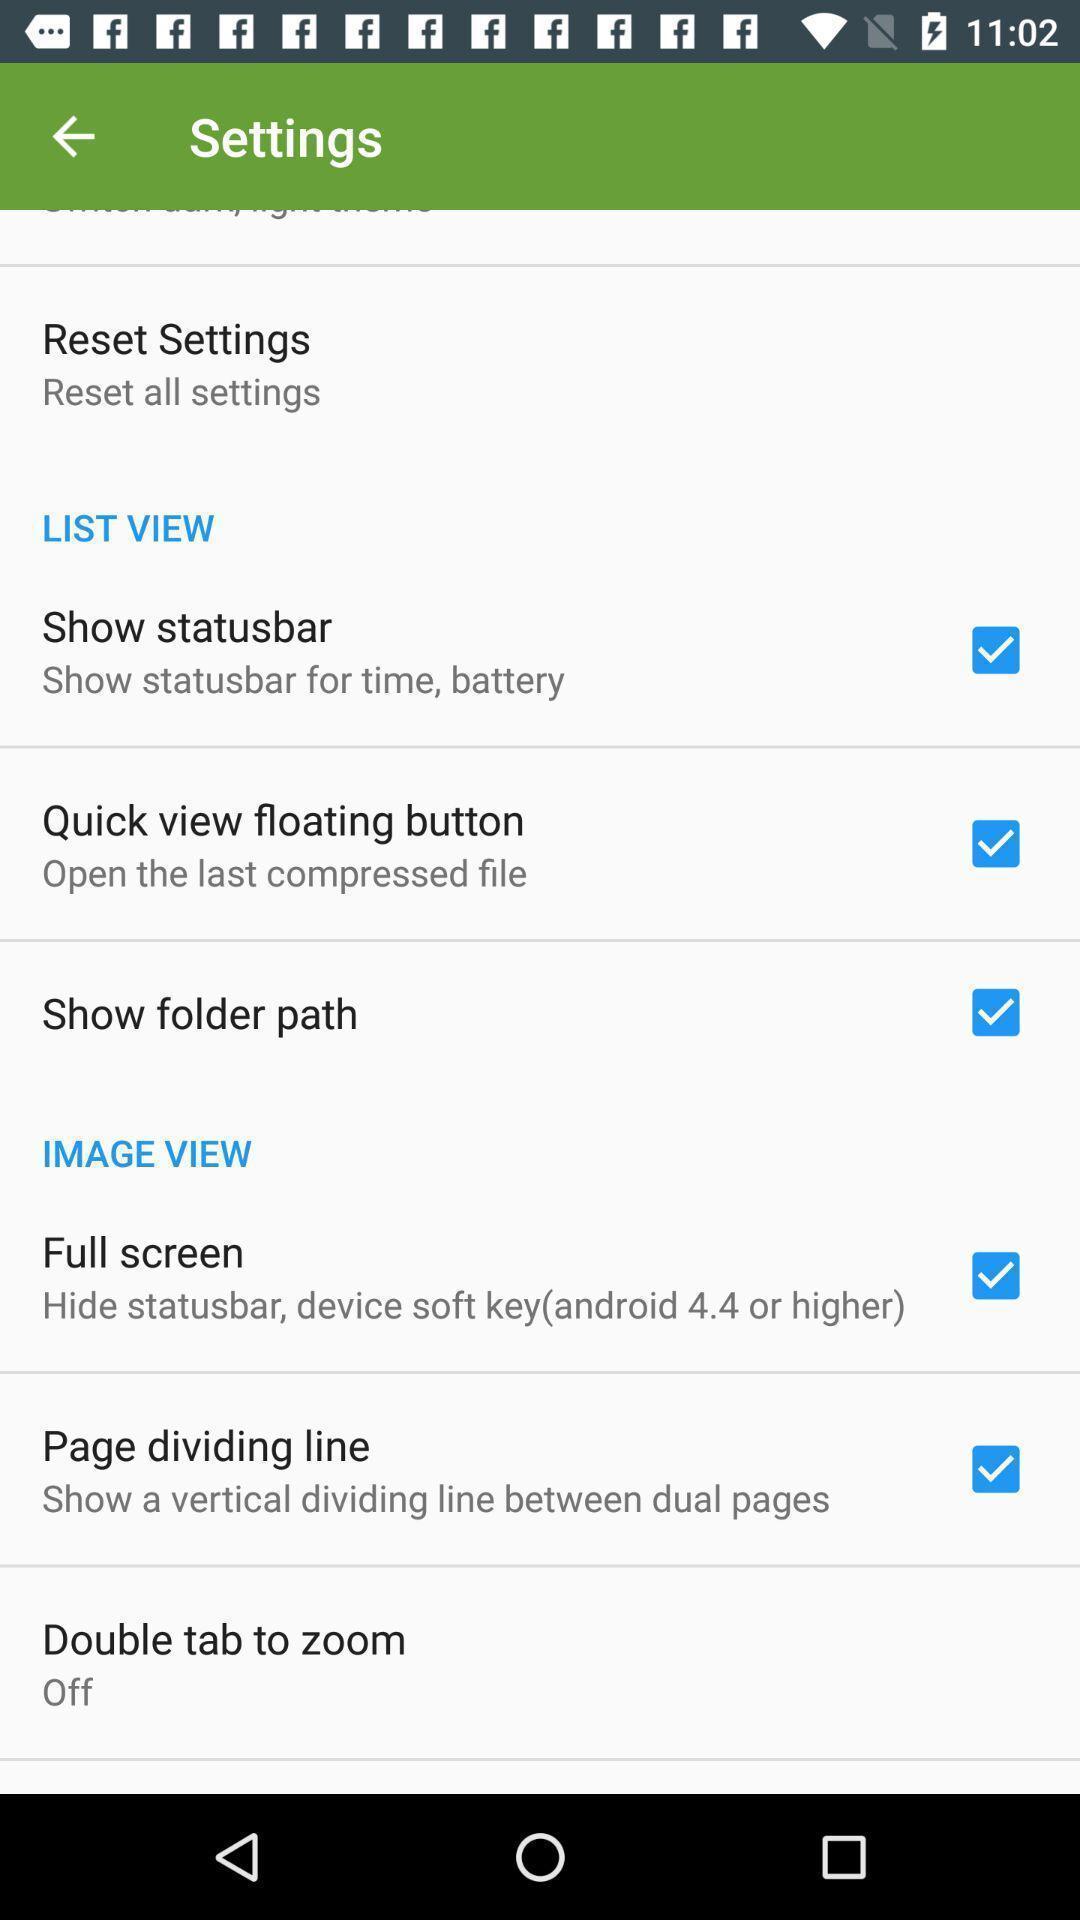Summarize the main components in this picture. Settings page. 